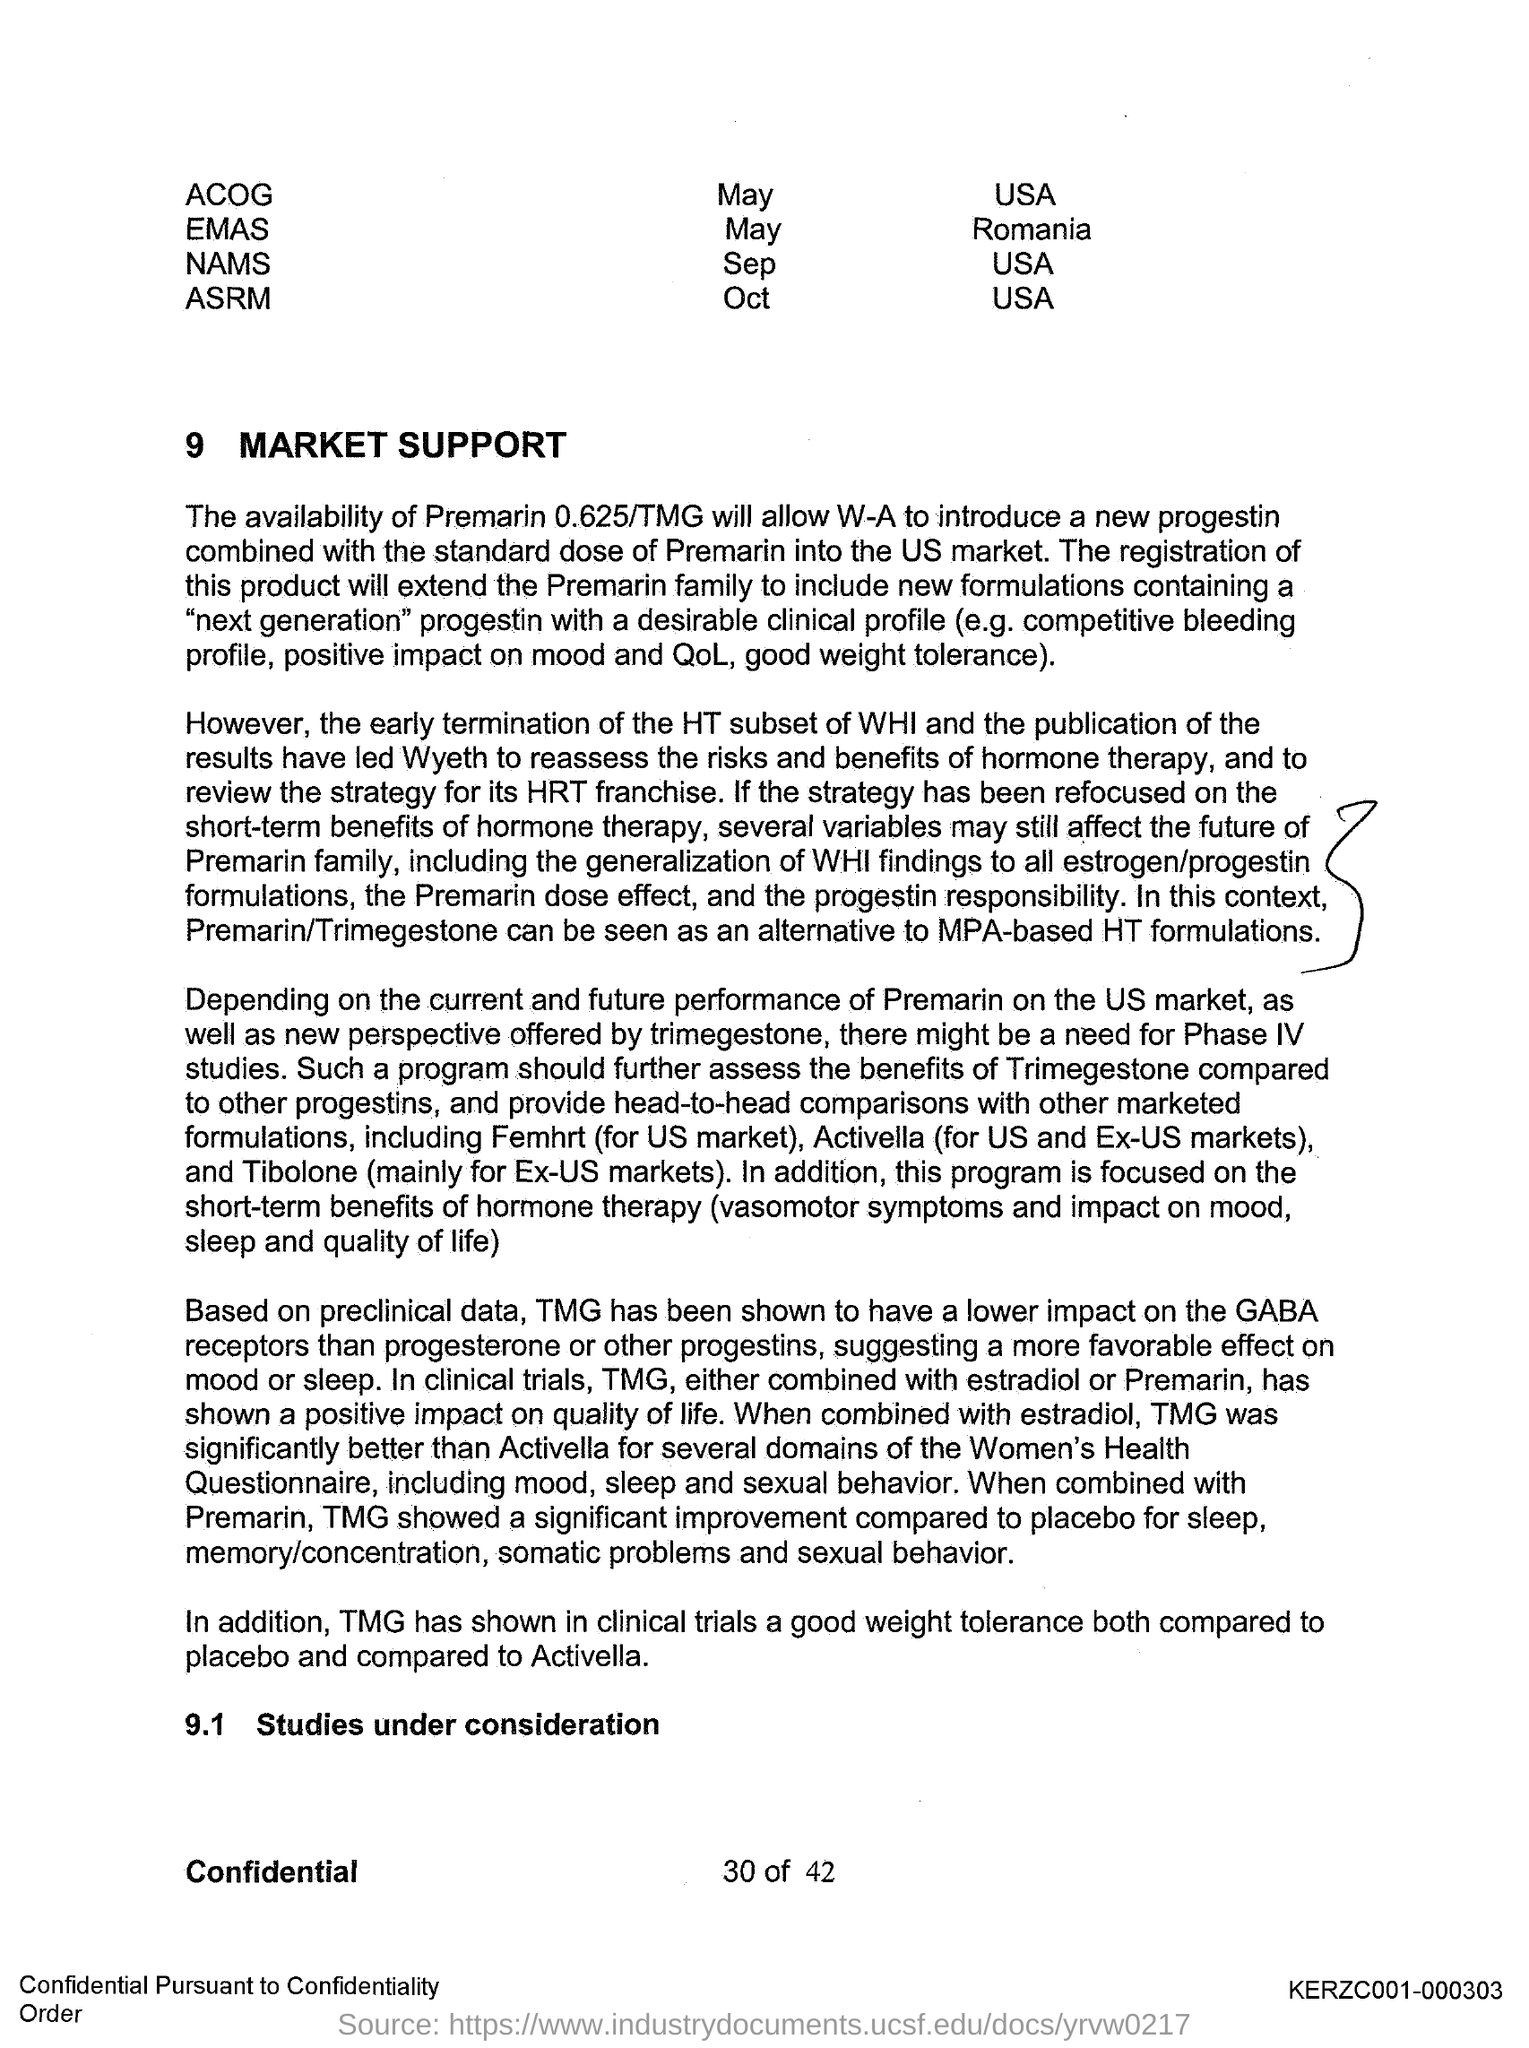What is the first title in the document?
Ensure brevity in your answer.  9 Market Support. What is the second title in the document?
Give a very brief answer. Studies under consideration. 